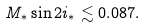<formula> <loc_0><loc_0><loc_500><loc_500>M _ { * } \sin 2 i _ { * } \lesssim 0 . 0 8 7 .</formula> 